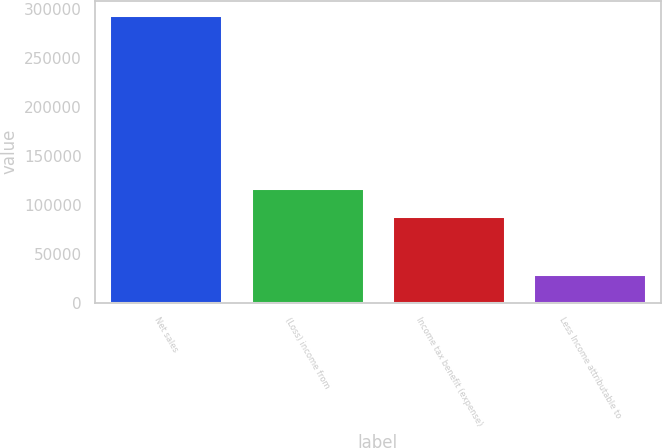Convert chart to OTSL. <chart><loc_0><loc_0><loc_500><loc_500><bar_chart><fcel>Net sales<fcel>(Loss) income from<fcel>Income tax benefit (expense)<fcel>Less Income attributable to<nl><fcel>293975<fcel>117628<fcel>88237.3<fcel>29455.1<nl></chart> 